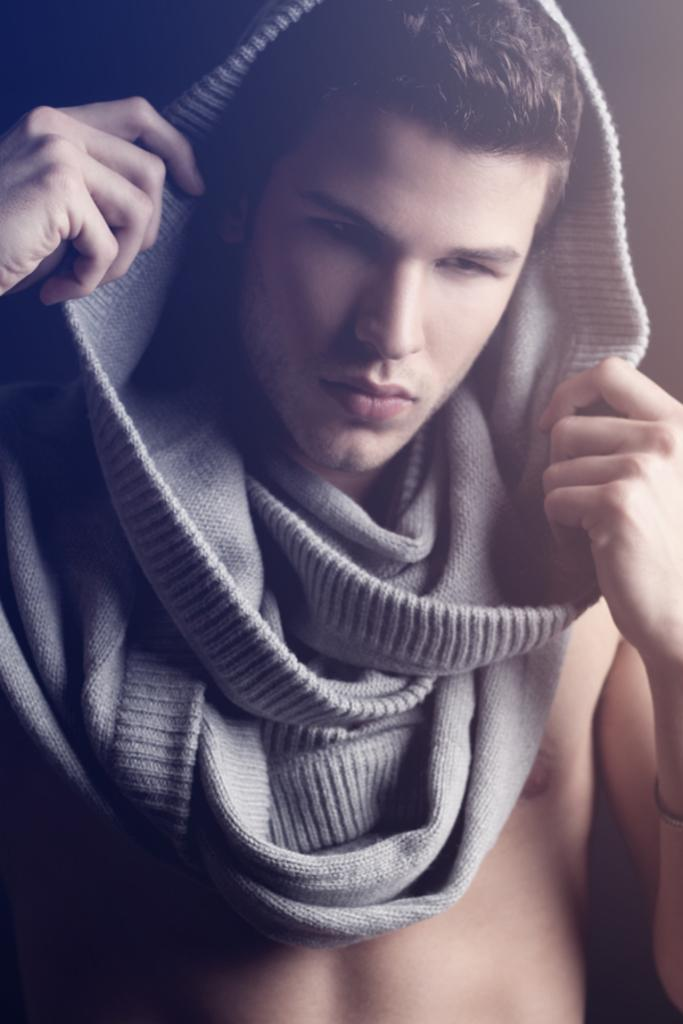What is the main subject in the foreground of the image? There is a man in the foreground of the image. What is the man wearing or holding over his head? The man has a stole over his head, and he is holding it. What is the color of the background in the image? The background of the image is black. How does the man compare his stole to a spade in the image? There is no comparison to a spade in the image; the man is simply holding a stole over his head. What time of day is depicted in the image? The time of day cannot be determined from the image, as there are no specific details about lighting or shadows. 